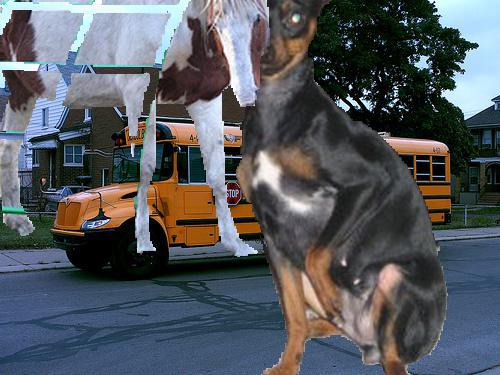What's unusual about the dog in the image? The dog appears to be disproportionately large compared to the bus and surroundings, which is not natural and indicates digital manipulation. 